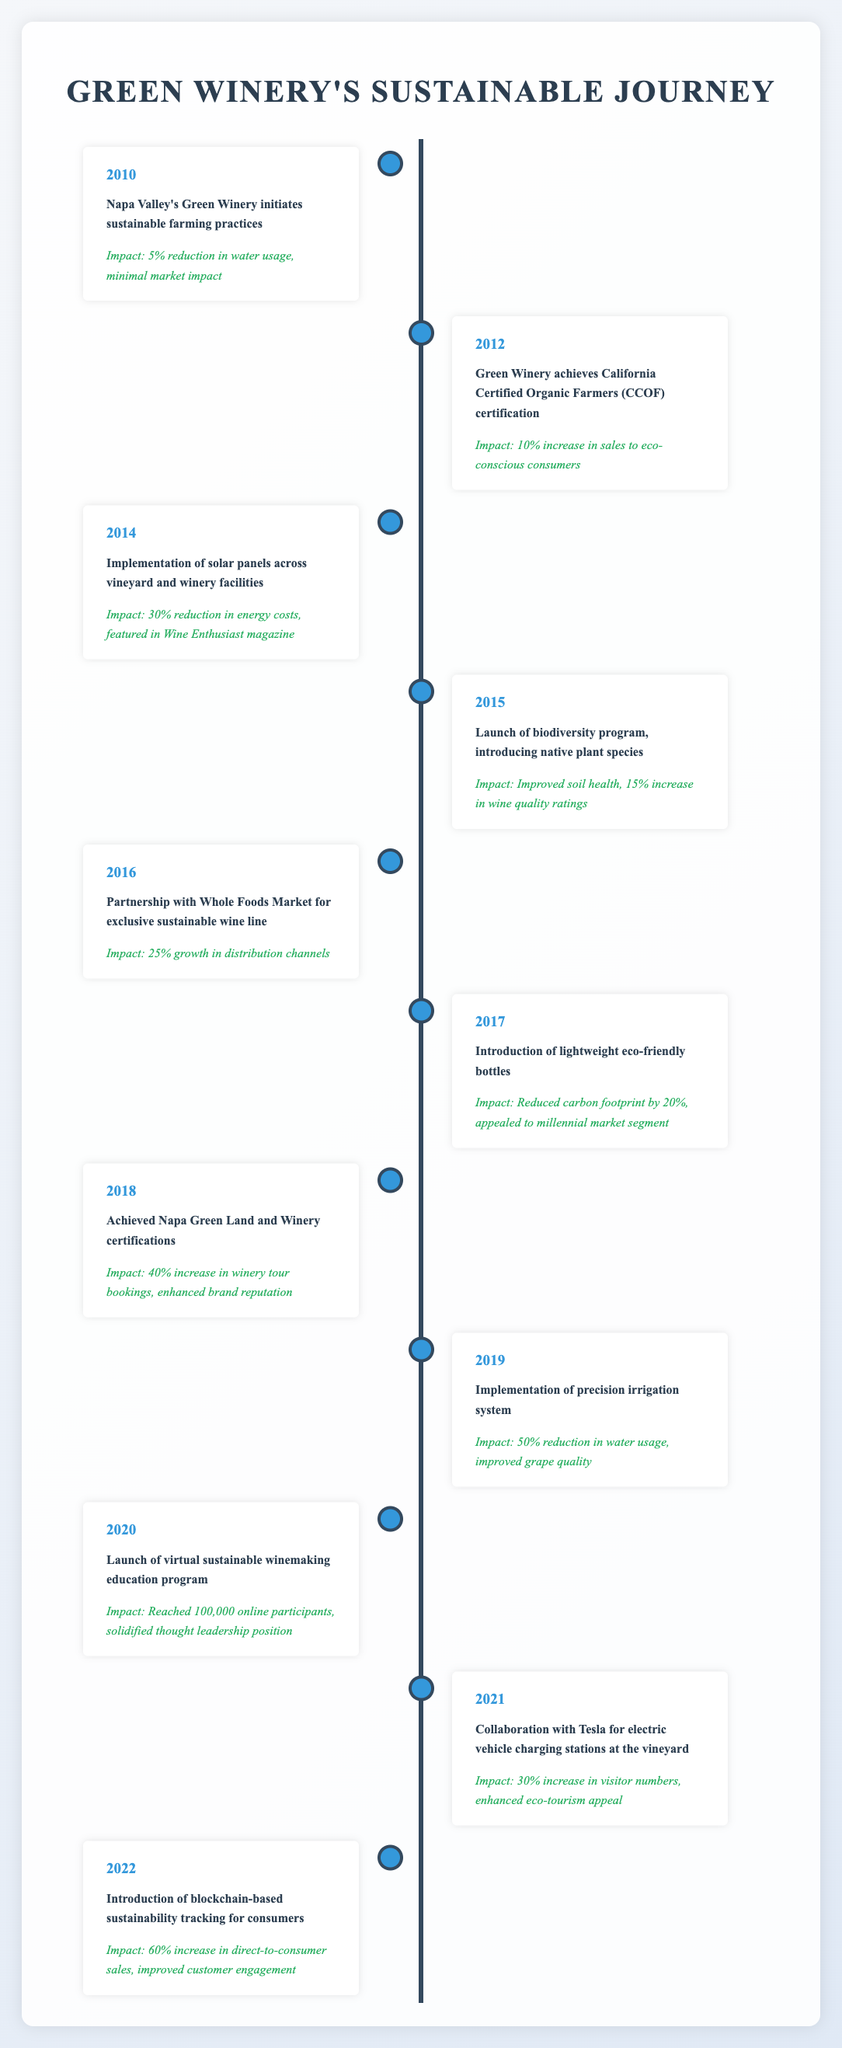What year did Napa Valley's Green Winery initiate sustainable farming practices? The table shows that the event "Napa Valley's Green Winery initiates sustainable farming practices" occurred in the year 2010.
Answer: 2010 What was the impact of Green Winery achieving CCOF certification in 2012? The table states that when Green Winery achieved California Certified Organic Farmers (CCOF) certification in 2012, it resulted in a "10% increase in sales to eco-conscious consumers."
Answer: 10% increase in sales How much did energy costs reduce after implementing solar panels in 2014? According to the table, the implementation of solar panels resulted in a "30% reduction in energy costs."
Answer: 30% What percentage of growth in distribution channels was achieved through the partnership with Whole Foods Market in 2016? The data indicates that the partnership with Whole Foods Market led to "25% growth in distribution channels" for Green Winery in 2016.
Answer: 25% Did the introduction of lightweight eco-friendly bottles reduce the carbon footprint? The table indicates that the introduction of lightweight eco-friendly bottles "reduced carbon footprint by 20%," confirming that the initiative did indeed have a positive impact on sustainability.
Answer: Yes What was the total percentage increase in winery tour bookings from 2018 after achieving Napa Green certifications? In 2018, after achieving Napa Green Land and Winery certifications, there was a "40% increase in winery tour bookings." There are no other events in this year to consider for addition or subtraction, so the total percentage increase is simply 40%.
Answer: 40% Which event in 2020 reached the most online participants? The table states that the "Launch of virtual sustainable winemaking education program" in 2020 reached "100,000 online participants," making it the event with the highest number of online participants.
Answer: 100,000 How many events led to a significant improvement in wine quality ratings? The table lists one event in 2015, the "Launch of biodiversity program," which specifically mentions a "15% increase in wine quality ratings." No other events mention quality ratings. Thus, there was only one event that achieved this.
Answer: 1 What was the trend in direct-to-consumer sales after the introduction of blockchain tracking in 2022? The introduction of blockchain-based sustainability tracking in 2022 led to a "60% increase in direct-to-consumer sales," indicating a positive trend in sales attributable to this initiative.
Answer: 60% increase 